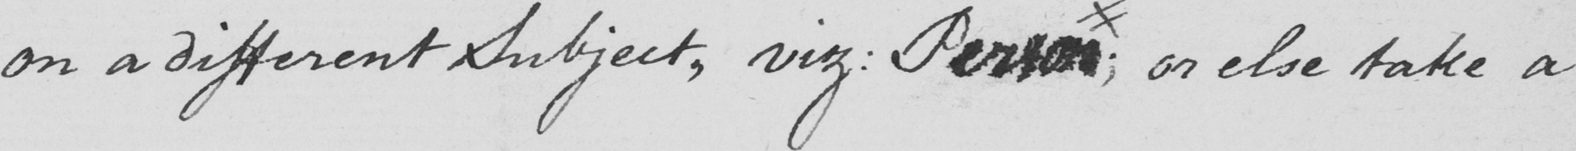What does this handwritten line say? on a different Subject , viz :  Person ; or else take a 